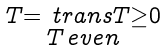<formula> <loc_0><loc_0><loc_500><loc_500>\begin{smallmatrix} T = \ t r a n s { T } \geq 0 \\ T \, e v e n \end{smallmatrix}</formula> 